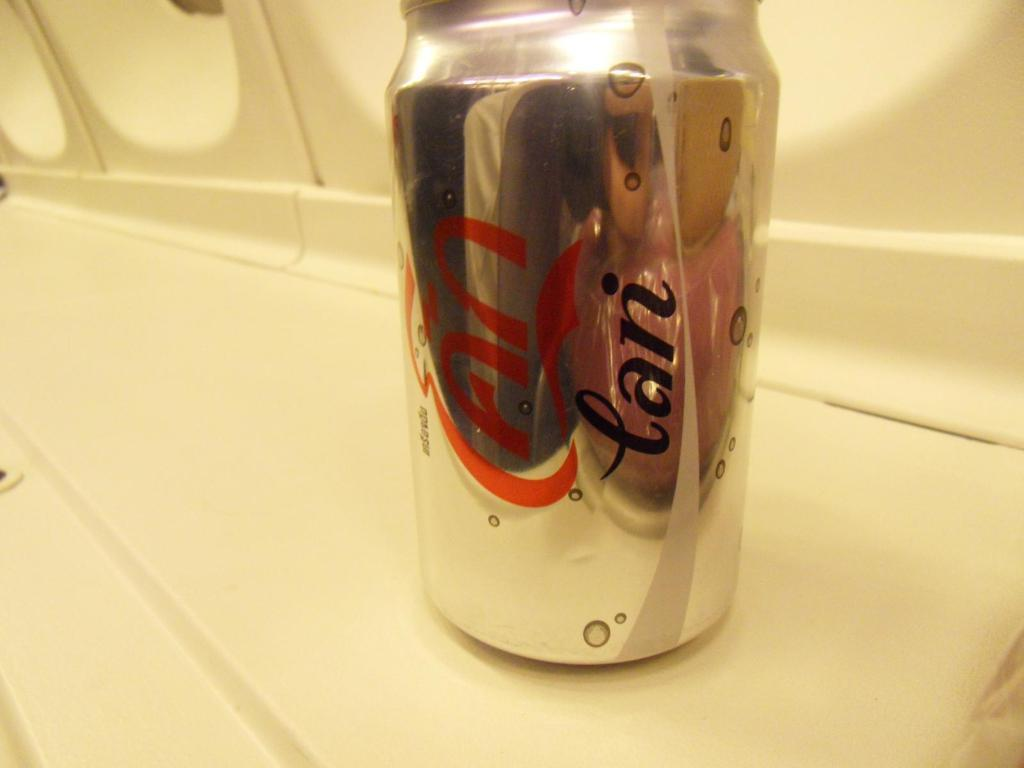<image>
Create a compact narrative representing the image presented. A can of soda labeled in a non-English language is on a white ledge. 